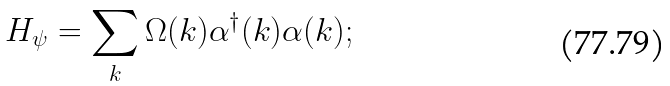Convert formula to latex. <formula><loc_0><loc_0><loc_500><loc_500>H _ { \psi } = \sum _ { k } \Omega ( k ) \alpha ^ { \dagger } ( k ) \alpha ( k ) ;</formula> 